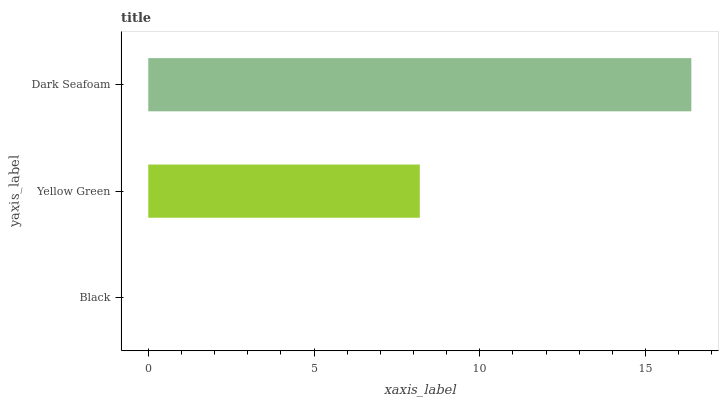Is Black the minimum?
Answer yes or no. Yes. Is Dark Seafoam the maximum?
Answer yes or no. Yes. Is Yellow Green the minimum?
Answer yes or no. No. Is Yellow Green the maximum?
Answer yes or no. No. Is Yellow Green greater than Black?
Answer yes or no. Yes. Is Black less than Yellow Green?
Answer yes or no. Yes. Is Black greater than Yellow Green?
Answer yes or no. No. Is Yellow Green less than Black?
Answer yes or no. No. Is Yellow Green the high median?
Answer yes or no. Yes. Is Yellow Green the low median?
Answer yes or no. Yes. Is Dark Seafoam the high median?
Answer yes or no. No. Is Black the low median?
Answer yes or no. No. 